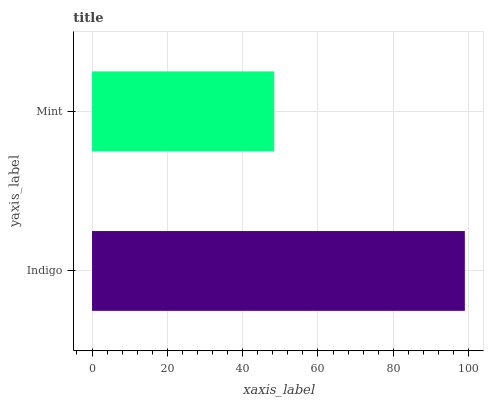Is Mint the minimum?
Answer yes or no. Yes. Is Indigo the maximum?
Answer yes or no. Yes. Is Mint the maximum?
Answer yes or no. No. Is Indigo greater than Mint?
Answer yes or no. Yes. Is Mint less than Indigo?
Answer yes or no. Yes. Is Mint greater than Indigo?
Answer yes or no. No. Is Indigo less than Mint?
Answer yes or no. No. Is Indigo the high median?
Answer yes or no. Yes. Is Mint the low median?
Answer yes or no. Yes. Is Mint the high median?
Answer yes or no. No. Is Indigo the low median?
Answer yes or no. No. 